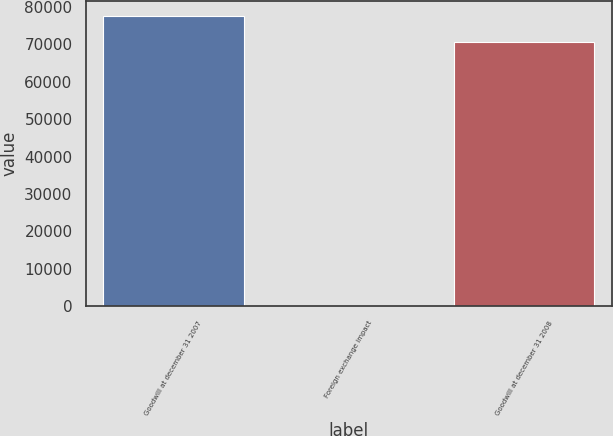Convert chart to OTSL. <chart><loc_0><loc_0><loc_500><loc_500><bar_chart><fcel>Goodwill at december 31 2007<fcel>Foreign exchange impact<fcel>Goodwill at december 31 2008<nl><fcel>77570.9<fcel>179<fcel>70519<nl></chart> 